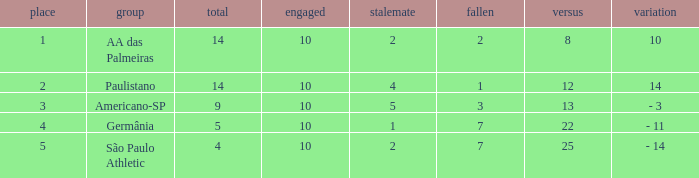What is the sum of Against when the lost is more than 7? None. 